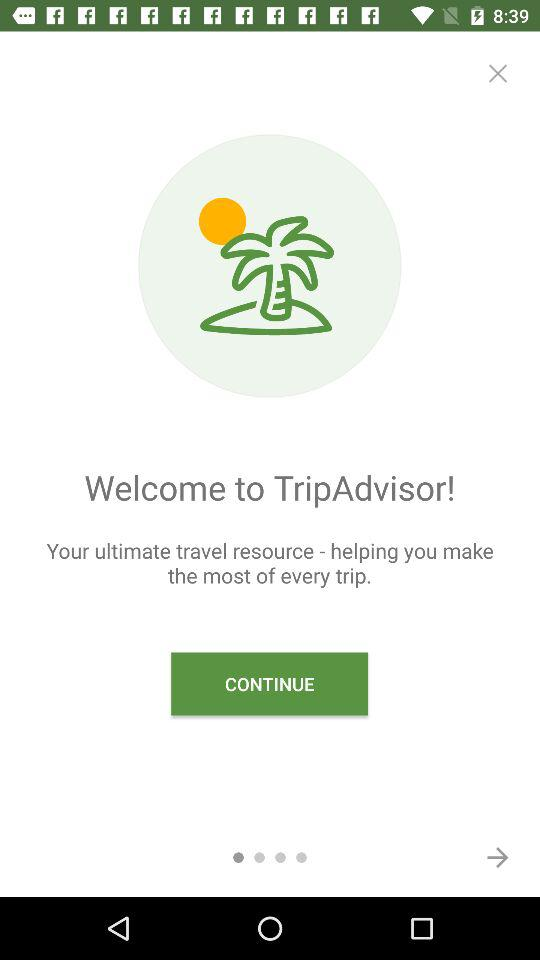What is the application name? The application name is "TripAdvisor". 